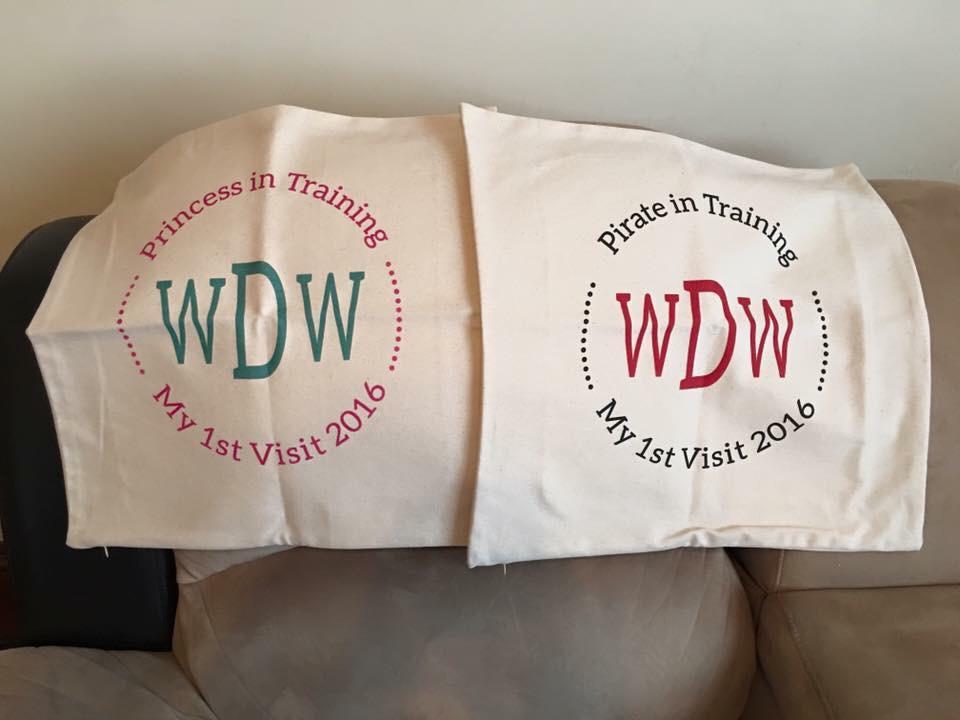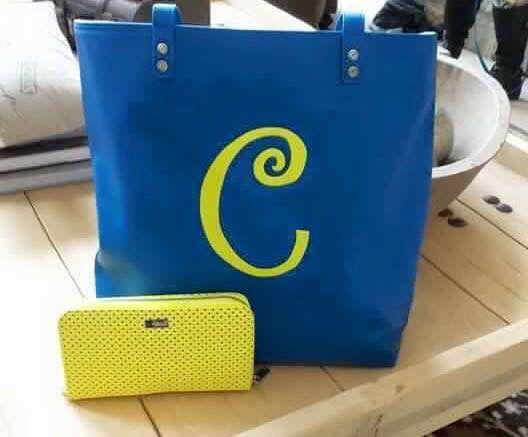The first image is the image on the left, the second image is the image on the right. Considering the images on both sides, is "There are an even number of pillows and no people." valid? Answer yes or no. No. The first image is the image on the left, the second image is the image on the right. Examine the images to the left and right. Is the description "The large squarish item in the foreground of one image is stamped at the center with a single alphabet letter." accurate? Answer yes or no. Yes. 